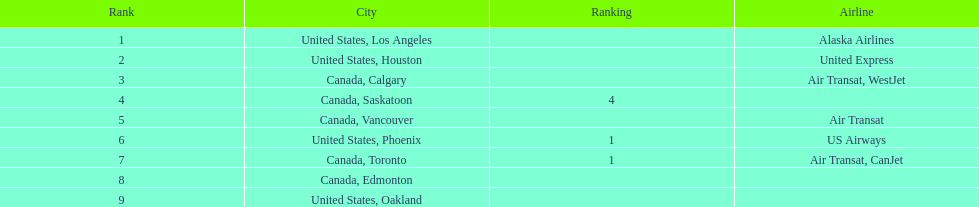How many more passengers flew to los angeles than to saskatoon from manzanillo airport in 2013? 12,467. 